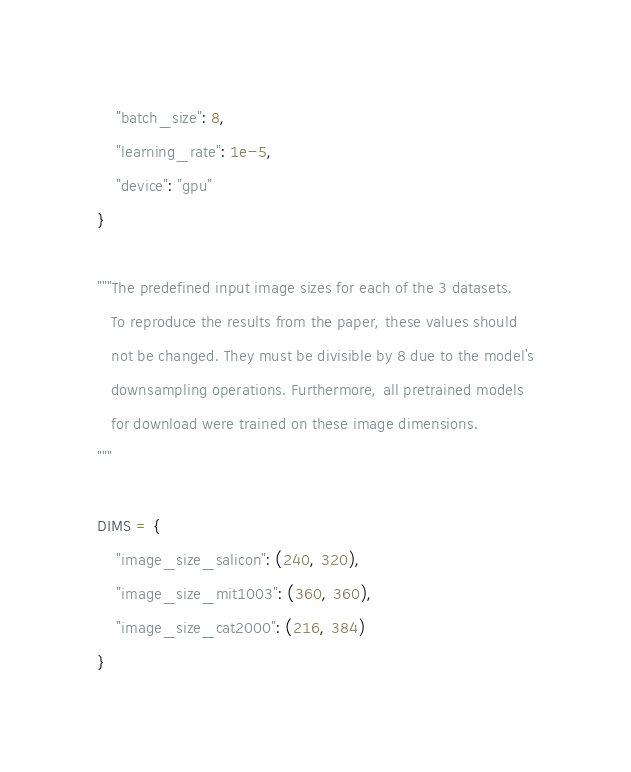<code> <loc_0><loc_0><loc_500><loc_500><_Python_>    "batch_size": 8,
    "learning_rate": 1e-5,
    "device": "gpu"
}

"""The predefined input image sizes for each of the 3 datasets.
   To reproduce the results from the paper, these values should
   not be changed. They must be divisible by 8 due to the model's
   downsampling operations. Furthermore, all pretrained models
   for download were trained on these image dimensions.
"""

DIMS = {
    "image_size_salicon": (240, 320),
    "image_size_mit1003": (360, 360),
    "image_size_cat2000": (216, 384)
}
</code> 